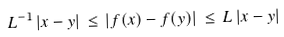Convert formula to latex. <formula><loc_0><loc_0><loc_500><loc_500>L ^ { - 1 } \, | x - y | \, \leq \, | f ( x ) - f ( y ) | \, \leq \, L \, | x - y |</formula> 